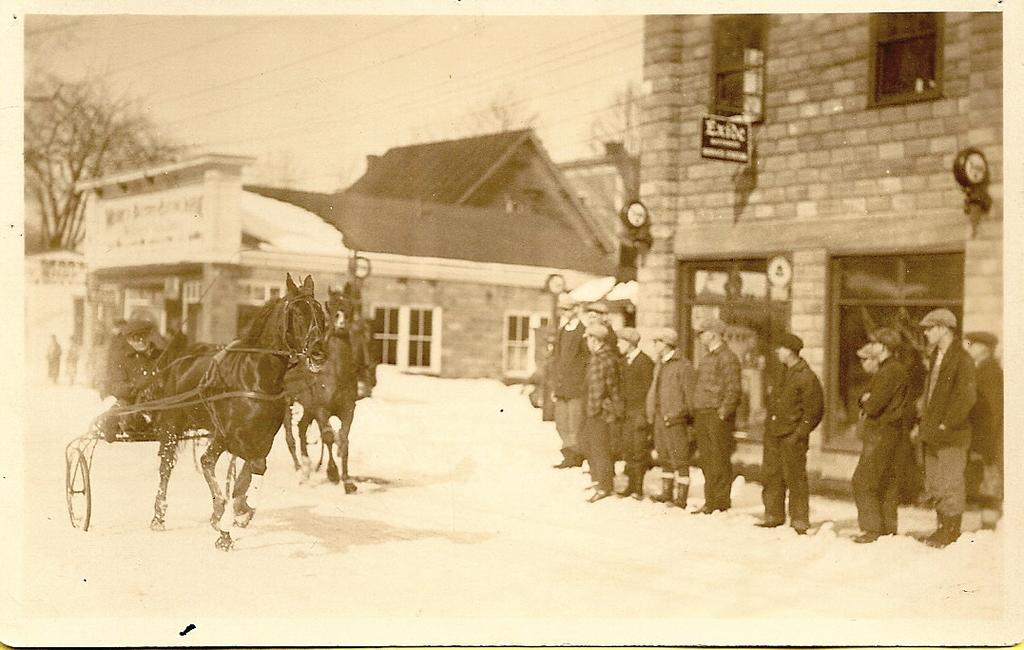What is the main subject of the image? There is a person riding a horse in the image. What are the other people in the image doing? There are people standing in the image. What can be seen in the background of the image? There are buildings, trees, a board, wires, and the sky visible in the background of the image. How does the person riding the horse use their mind to control the horse in the image? The image does not provide information about how the person is controlling the horse, nor does it show any indication of the person using their mind to do so. 